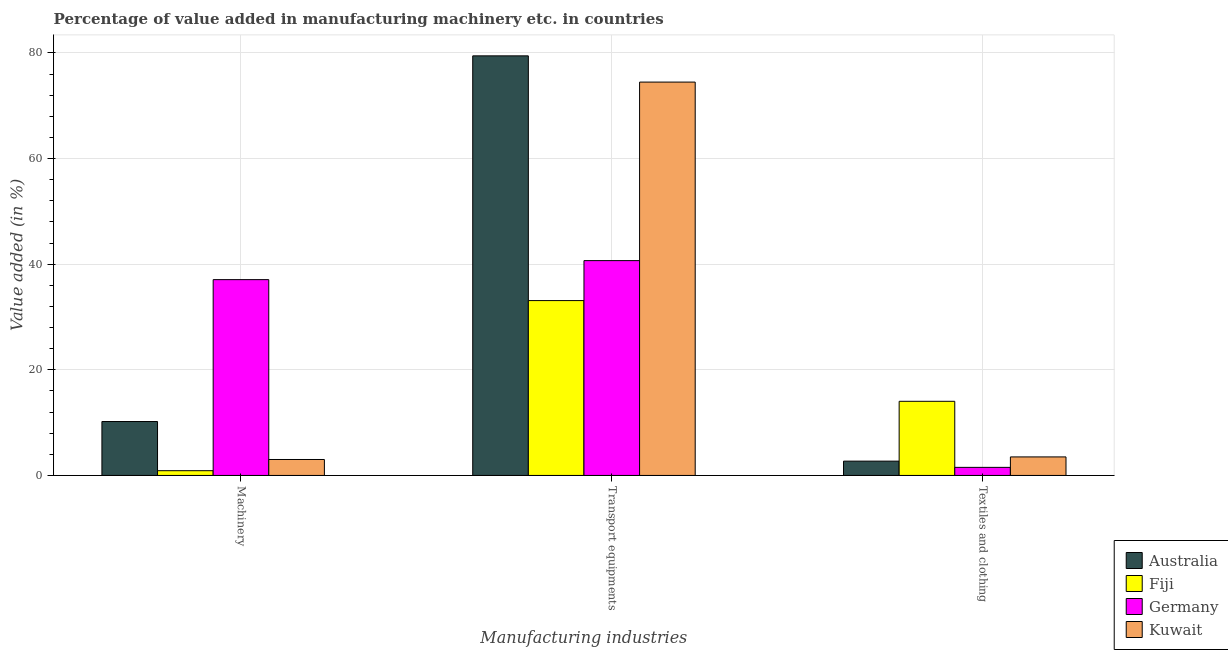How many groups of bars are there?
Your answer should be very brief. 3. Are the number of bars per tick equal to the number of legend labels?
Offer a terse response. Yes. Are the number of bars on each tick of the X-axis equal?
Provide a short and direct response. Yes. How many bars are there on the 1st tick from the left?
Your answer should be very brief. 4. What is the label of the 2nd group of bars from the left?
Offer a terse response. Transport equipments. What is the value added in manufacturing machinery in Australia?
Ensure brevity in your answer.  10.21. Across all countries, what is the maximum value added in manufacturing textile and clothing?
Provide a short and direct response. 14.04. Across all countries, what is the minimum value added in manufacturing transport equipments?
Give a very brief answer. 33.11. In which country was the value added in manufacturing machinery minimum?
Offer a very short reply. Fiji. What is the total value added in manufacturing textile and clothing in the graph?
Offer a very short reply. 21.78. What is the difference between the value added in manufacturing transport equipments in Australia and that in Kuwait?
Offer a very short reply. 4.97. What is the difference between the value added in manufacturing textile and clothing in Kuwait and the value added in manufacturing transport equipments in Australia?
Your response must be concise. -75.94. What is the average value added in manufacturing textile and clothing per country?
Offer a very short reply. 5.45. What is the difference between the value added in manufacturing machinery and value added in manufacturing textile and clothing in Australia?
Ensure brevity in your answer.  7.5. What is the ratio of the value added in manufacturing transport equipments in Kuwait to that in Fiji?
Keep it short and to the point. 2.25. Is the value added in manufacturing textile and clothing in Fiji less than that in Germany?
Your answer should be compact. No. Is the difference between the value added in manufacturing textile and clothing in Germany and Australia greater than the difference between the value added in manufacturing machinery in Germany and Australia?
Make the answer very short. No. What is the difference between the highest and the second highest value added in manufacturing machinery?
Your answer should be compact. 26.86. What is the difference between the highest and the lowest value added in manufacturing textile and clothing?
Provide a short and direct response. 12.51. In how many countries, is the value added in manufacturing transport equipments greater than the average value added in manufacturing transport equipments taken over all countries?
Your response must be concise. 2. Is the sum of the value added in manufacturing transport equipments in Kuwait and Germany greater than the maximum value added in manufacturing textile and clothing across all countries?
Keep it short and to the point. Yes. What does the 4th bar from the left in Textiles and clothing represents?
Your response must be concise. Kuwait. Is it the case that in every country, the sum of the value added in manufacturing machinery and value added in manufacturing transport equipments is greater than the value added in manufacturing textile and clothing?
Your response must be concise. Yes. Are all the bars in the graph horizontal?
Offer a terse response. No. Are the values on the major ticks of Y-axis written in scientific E-notation?
Give a very brief answer. No. Does the graph contain any zero values?
Your response must be concise. No. Where does the legend appear in the graph?
Offer a terse response. Bottom right. How many legend labels are there?
Provide a succinct answer. 4. What is the title of the graph?
Your response must be concise. Percentage of value added in manufacturing machinery etc. in countries. Does "Least developed countries" appear as one of the legend labels in the graph?
Your response must be concise. No. What is the label or title of the X-axis?
Offer a terse response. Manufacturing industries. What is the label or title of the Y-axis?
Your answer should be compact. Value added (in %). What is the Value added (in %) of Australia in Machinery?
Your answer should be compact. 10.21. What is the Value added (in %) in Fiji in Machinery?
Your response must be concise. 0.9. What is the Value added (in %) in Germany in Machinery?
Give a very brief answer. 37.07. What is the Value added (in %) in Kuwait in Machinery?
Offer a very short reply. 3.02. What is the Value added (in %) of Australia in Transport equipments?
Your response must be concise. 79.44. What is the Value added (in %) of Fiji in Transport equipments?
Your response must be concise. 33.11. What is the Value added (in %) in Germany in Transport equipments?
Your response must be concise. 40.67. What is the Value added (in %) in Kuwait in Transport equipments?
Keep it short and to the point. 74.48. What is the Value added (in %) of Australia in Textiles and clothing?
Keep it short and to the point. 2.71. What is the Value added (in %) of Fiji in Textiles and clothing?
Your response must be concise. 14.04. What is the Value added (in %) in Germany in Textiles and clothing?
Provide a short and direct response. 1.53. What is the Value added (in %) in Kuwait in Textiles and clothing?
Make the answer very short. 3.51. Across all Manufacturing industries, what is the maximum Value added (in %) in Australia?
Provide a succinct answer. 79.44. Across all Manufacturing industries, what is the maximum Value added (in %) in Fiji?
Provide a succinct answer. 33.11. Across all Manufacturing industries, what is the maximum Value added (in %) in Germany?
Offer a very short reply. 40.67. Across all Manufacturing industries, what is the maximum Value added (in %) in Kuwait?
Offer a very short reply. 74.48. Across all Manufacturing industries, what is the minimum Value added (in %) in Australia?
Make the answer very short. 2.71. Across all Manufacturing industries, what is the minimum Value added (in %) in Fiji?
Provide a short and direct response. 0.9. Across all Manufacturing industries, what is the minimum Value added (in %) in Germany?
Keep it short and to the point. 1.53. Across all Manufacturing industries, what is the minimum Value added (in %) in Kuwait?
Provide a short and direct response. 3.02. What is the total Value added (in %) in Australia in the graph?
Offer a very short reply. 92.36. What is the total Value added (in %) of Fiji in the graph?
Ensure brevity in your answer.  48.04. What is the total Value added (in %) of Germany in the graph?
Your answer should be very brief. 79.28. What is the total Value added (in %) in Kuwait in the graph?
Ensure brevity in your answer.  81.01. What is the difference between the Value added (in %) of Australia in Machinery and that in Transport equipments?
Offer a very short reply. -69.23. What is the difference between the Value added (in %) of Fiji in Machinery and that in Transport equipments?
Offer a very short reply. -32.21. What is the difference between the Value added (in %) of Germany in Machinery and that in Transport equipments?
Your answer should be very brief. -3.6. What is the difference between the Value added (in %) in Kuwait in Machinery and that in Transport equipments?
Provide a short and direct response. -71.46. What is the difference between the Value added (in %) in Australia in Machinery and that in Textiles and clothing?
Offer a terse response. 7.5. What is the difference between the Value added (in %) of Fiji in Machinery and that in Textiles and clothing?
Give a very brief answer. -13.14. What is the difference between the Value added (in %) of Germany in Machinery and that in Textiles and clothing?
Offer a terse response. 35.54. What is the difference between the Value added (in %) in Kuwait in Machinery and that in Textiles and clothing?
Ensure brevity in your answer.  -0.49. What is the difference between the Value added (in %) in Australia in Transport equipments and that in Textiles and clothing?
Provide a short and direct response. 76.73. What is the difference between the Value added (in %) of Fiji in Transport equipments and that in Textiles and clothing?
Ensure brevity in your answer.  19.07. What is the difference between the Value added (in %) of Germany in Transport equipments and that in Textiles and clothing?
Your answer should be very brief. 39.14. What is the difference between the Value added (in %) of Kuwait in Transport equipments and that in Textiles and clothing?
Give a very brief answer. 70.97. What is the difference between the Value added (in %) in Australia in Machinery and the Value added (in %) in Fiji in Transport equipments?
Your response must be concise. -22.9. What is the difference between the Value added (in %) in Australia in Machinery and the Value added (in %) in Germany in Transport equipments?
Your response must be concise. -30.46. What is the difference between the Value added (in %) in Australia in Machinery and the Value added (in %) in Kuwait in Transport equipments?
Your answer should be compact. -64.27. What is the difference between the Value added (in %) in Fiji in Machinery and the Value added (in %) in Germany in Transport equipments?
Ensure brevity in your answer.  -39.78. What is the difference between the Value added (in %) in Fiji in Machinery and the Value added (in %) in Kuwait in Transport equipments?
Your answer should be very brief. -73.58. What is the difference between the Value added (in %) of Germany in Machinery and the Value added (in %) of Kuwait in Transport equipments?
Your answer should be very brief. -37.4. What is the difference between the Value added (in %) in Australia in Machinery and the Value added (in %) in Fiji in Textiles and clothing?
Make the answer very short. -3.83. What is the difference between the Value added (in %) in Australia in Machinery and the Value added (in %) in Germany in Textiles and clothing?
Your response must be concise. 8.68. What is the difference between the Value added (in %) of Australia in Machinery and the Value added (in %) of Kuwait in Textiles and clothing?
Provide a short and direct response. 6.7. What is the difference between the Value added (in %) in Fiji in Machinery and the Value added (in %) in Germany in Textiles and clothing?
Give a very brief answer. -0.63. What is the difference between the Value added (in %) of Fiji in Machinery and the Value added (in %) of Kuwait in Textiles and clothing?
Give a very brief answer. -2.61. What is the difference between the Value added (in %) of Germany in Machinery and the Value added (in %) of Kuwait in Textiles and clothing?
Make the answer very short. 33.57. What is the difference between the Value added (in %) in Australia in Transport equipments and the Value added (in %) in Fiji in Textiles and clothing?
Your answer should be compact. 65.41. What is the difference between the Value added (in %) of Australia in Transport equipments and the Value added (in %) of Germany in Textiles and clothing?
Provide a short and direct response. 77.92. What is the difference between the Value added (in %) in Australia in Transport equipments and the Value added (in %) in Kuwait in Textiles and clothing?
Offer a very short reply. 75.94. What is the difference between the Value added (in %) of Fiji in Transport equipments and the Value added (in %) of Germany in Textiles and clothing?
Keep it short and to the point. 31.58. What is the difference between the Value added (in %) of Fiji in Transport equipments and the Value added (in %) of Kuwait in Textiles and clothing?
Your answer should be very brief. 29.6. What is the difference between the Value added (in %) in Germany in Transport equipments and the Value added (in %) in Kuwait in Textiles and clothing?
Provide a short and direct response. 37.17. What is the average Value added (in %) of Australia per Manufacturing industries?
Offer a terse response. 30.79. What is the average Value added (in %) of Fiji per Manufacturing industries?
Your answer should be compact. 16.01. What is the average Value added (in %) in Germany per Manufacturing industries?
Your response must be concise. 26.43. What is the average Value added (in %) of Kuwait per Manufacturing industries?
Ensure brevity in your answer.  27. What is the difference between the Value added (in %) of Australia and Value added (in %) of Fiji in Machinery?
Provide a short and direct response. 9.31. What is the difference between the Value added (in %) of Australia and Value added (in %) of Germany in Machinery?
Give a very brief answer. -26.86. What is the difference between the Value added (in %) of Australia and Value added (in %) of Kuwait in Machinery?
Give a very brief answer. 7.19. What is the difference between the Value added (in %) in Fiji and Value added (in %) in Germany in Machinery?
Your answer should be compact. -36.18. What is the difference between the Value added (in %) in Fiji and Value added (in %) in Kuwait in Machinery?
Give a very brief answer. -2.12. What is the difference between the Value added (in %) in Germany and Value added (in %) in Kuwait in Machinery?
Give a very brief answer. 34.05. What is the difference between the Value added (in %) in Australia and Value added (in %) in Fiji in Transport equipments?
Your response must be concise. 46.34. What is the difference between the Value added (in %) in Australia and Value added (in %) in Germany in Transport equipments?
Your answer should be very brief. 38.77. What is the difference between the Value added (in %) of Australia and Value added (in %) of Kuwait in Transport equipments?
Make the answer very short. 4.97. What is the difference between the Value added (in %) of Fiji and Value added (in %) of Germany in Transport equipments?
Provide a succinct answer. -7.57. What is the difference between the Value added (in %) of Fiji and Value added (in %) of Kuwait in Transport equipments?
Provide a succinct answer. -41.37. What is the difference between the Value added (in %) in Germany and Value added (in %) in Kuwait in Transport equipments?
Give a very brief answer. -33.8. What is the difference between the Value added (in %) in Australia and Value added (in %) in Fiji in Textiles and clothing?
Offer a very short reply. -11.33. What is the difference between the Value added (in %) in Australia and Value added (in %) in Germany in Textiles and clothing?
Provide a succinct answer. 1.18. What is the difference between the Value added (in %) of Australia and Value added (in %) of Kuwait in Textiles and clothing?
Offer a very short reply. -0.8. What is the difference between the Value added (in %) of Fiji and Value added (in %) of Germany in Textiles and clothing?
Provide a succinct answer. 12.51. What is the difference between the Value added (in %) of Fiji and Value added (in %) of Kuwait in Textiles and clothing?
Offer a terse response. 10.53. What is the difference between the Value added (in %) of Germany and Value added (in %) of Kuwait in Textiles and clothing?
Ensure brevity in your answer.  -1.98. What is the ratio of the Value added (in %) of Australia in Machinery to that in Transport equipments?
Provide a succinct answer. 0.13. What is the ratio of the Value added (in %) in Fiji in Machinery to that in Transport equipments?
Provide a succinct answer. 0.03. What is the ratio of the Value added (in %) in Germany in Machinery to that in Transport equipments?
Make the answer very short. 0.91. What is the ratio of the Value added (in %) in Kuwait in Machinery to that in Transport equipments?
Keep it short and to the point. 0.04. What is the ratio of the Value added (in %) in Australia in Machinery to that in Textiles and clothing?
Offer a terse response. 3.77. What is the ratio of the Value added (in %) in Fiji in Machinery to that in Textiles and clothing?
Your answer should be compact. 0.06. What is the ratio of the Value added (in %) of Germany in Machinery to that in Textiles and clothing?
Give a very brief answer. 24.25. What is the ratio of the Value added (in %) in Kuwait in Machinery to that in Textiles and clothing?
Offer a terse response. 0.86. What is the ratio of the Value added (in %) in Australia in Transport equipments to that in Textiles and clothing?
Your response must be concise. 29.31. What is the ratio of the Value added (in %) in Fiji in Transport equipments to that in Textiles and clothing?
Offer a very short reply. 2.36. What is the ratio of the Value added (in %) of Germany in Transport equipments to that in Textiles and clothing?
Keep it short and to the point. 26.6. What is the ratio of the Value added (in %) of Kuwait in Transport equipments to that in Textiles and clothing?
Keep it short and to the point. 21.23. What is the difference between the highest and the second highest Value added (in %) in Australia?
Make the answer very short. 69.23. What is the difference between the highest and the second highest Value added (in %) of Fiji?
Offer a terse response. 19.07. What is the difference between the highest and the second highest Value added (in %) of Germany?
Your response must be concise. 3.6. What is the difference between the highest and the second highest Value added (in %) in Kuwait?
Provide a short and direct response. 70.97. What is the difference between the highest and the lowest Value added (in %) in Australia?
Make the answer very short. 76.73. What is the difference between the highest and the lowest Value added (in %) in Fiji?
Ensure brevity in your answer.  32.21. What is the difference between the highest and the lowest Value added (in %) in Germany?
Offer a terse response. 39.14. What is the difference between the highest and the lowest Value added (in %) in Kuwait?
Keep it short and to the point. 71.46. 